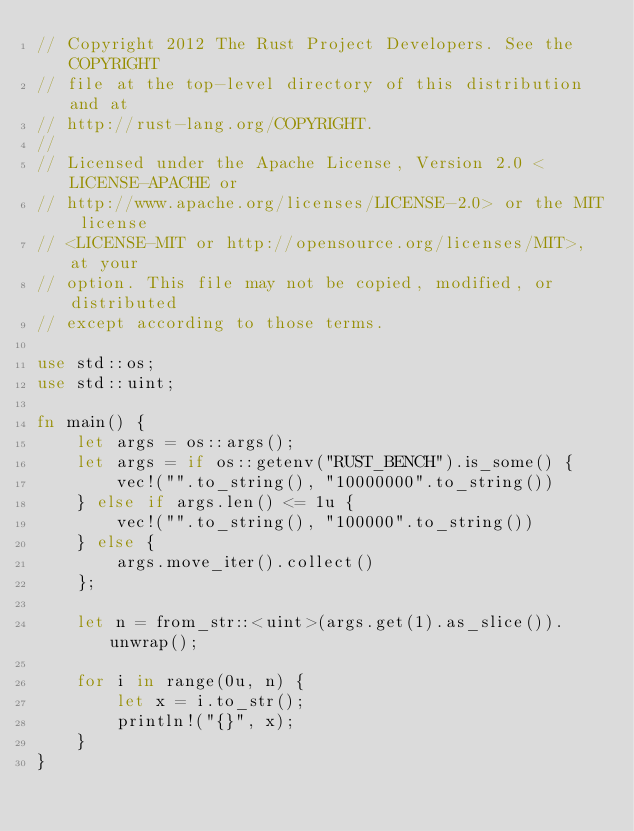Convert code to text. <code><loc_0><loc_0><loc_500><loc_500><_Rust_>// Copyright 2012 The Rust Project Developers. See the COPYRIGHT
// file at the top-level directory of this distribution and at
// http://rust-lang.org/COPYRIGHT.
//
// Licensed under the Apache License, Version 2.0 <LICENSE-APACHE or
// http://www.apache.org/licenses/LICENSE-2.0> or the MIT license
// <LICENSE-MIT or http://opensource.org/licenses/MIT>, at your
// option. This file may not be copied, modified, or distributed
// except according to those terms.

use std::os;
use std::uint;

fn main() {
    let args = os::args();
    let args = if os::getenv("RUST_BENCH").is_some() {
        vec!("".to_string(), "10000000".to_string())
    } else if args.len() <= 1u {
        vec!("".to_string(), "100000".to_string())
    } else {
        args.move_iter().collect()
    };

    let n = from_str::<uint>(args.get(1).as_slice()).unwrap();

    for i in range(0u, n) {
        let x = i.to_str();
        println!("{}", x);
    }
}
</code> 